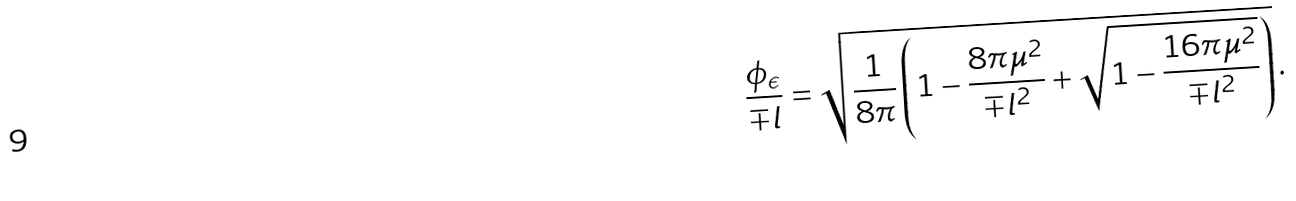<formula> <loc_0><loc_0><loc_500><loc_500>\frac { \phi _ { \epsilon } } { \mp l } = \sqrt { \frac { 1 } { 8 \pi } \left ( 1 - \frac { 8 \pi \mu ^ { 2 } } { \mp l ^ { 2 } } + \sqrt { 1 - \frac { 1 6 \pi \mu ^ { 2 } } { \mp l ^ { 2 } } } \right ) } \, .</formula> 